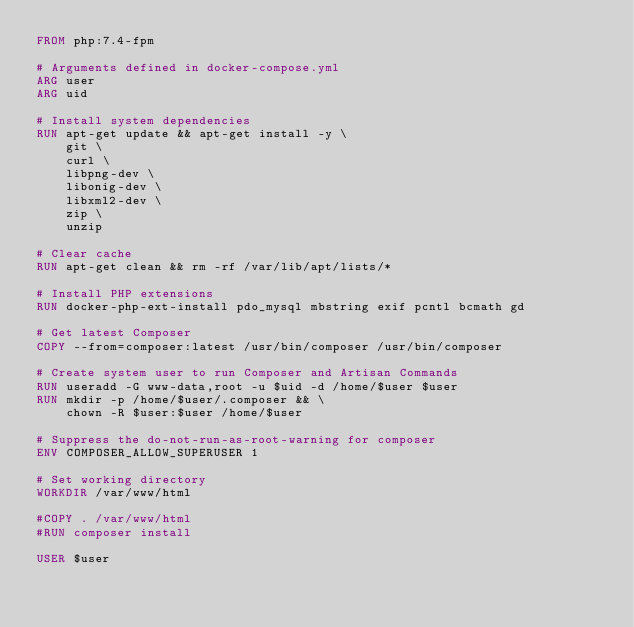Convert code to text. <code><loc_0><loc_0><loc_500><loc_500><_Dockerfile_>FROM php:7.4-fpm

# Arguments defined in docker-compose.yml
ARG user
ARG uid

# Install system dependencies
RUN apt-get update && apt-get install -y \
    git \
    curl \
    libpng-dev \
    libonig-dev \
    libxml2-dev \
    zip \
    unzip

# Clear cache
RUN apt-get clean && rm -rf /var/lib/apt/lists/*

# Install PHP extensions
RUN docker-php-ext-install pdo_mysql mbstring exif pcntl bcmath gd

# Get latest Composer
COPY --from=composer:latest /usr/bin/composer /usr/bin/composer

# Create system user to run Composer and Artisan Commands
RUN useradd -G www-data,root -u $uid -d /home/$user $user
RUN mkdir -p /home/$user/.composer && \
    chown -R $user:$user /home/$user

# Suppress the do-not-run-as-root-warning for composer
ENV COMPOSER_ALLOW_SUPERUSER 1

# Set working directory
WORKDIR /var/www/html

#COPY . /var/www/html
#RUN composer install

USER $user
</code> 